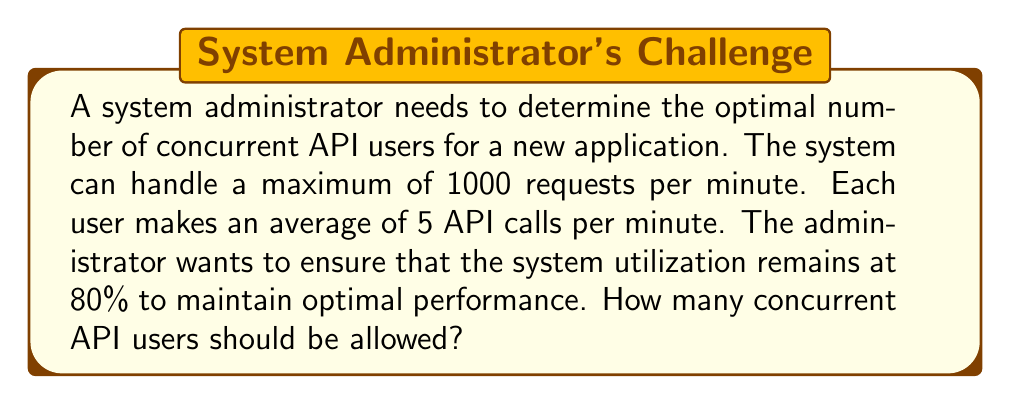Help me with this question. To solve this problem, we need to follow these steps:

1. Calculate the total number of requests the system can handle at 80% utilization:
   $$\text{Requests at 80% utilization} = 1000 \times 0.80 = 800 \text{ requests per minute}$$

2. Calculate the number of users that can be supported:
   Let $x$ be the number of concurrent users.
   Each user makes 5 API calls per minute.
   
   Set up the equation:
   $$5x = 800$$

3. Solve for $x$:
   $$x = \frac{800}{5} = 160$$

Therefore, the system can support 160 concurrent API users while maintaining 80% utilization.
Answer: 160 concurrent API users 